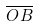<formula> <loc_0><loc_0><loc_500><loc_500>\overline { O B }</formula> 